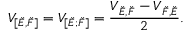Convert formula to latex. <formula><loc_0><loc_0><loc_500><loc_500>V _ { [ \check { E } , \check { F } ] } = V _ { [ \check { E } ; \check { F } ] } = \frac { V _ { \check { E } , \check { F } } - V _ { \check { F } , \check { E } } } { 2 } .</formula> 